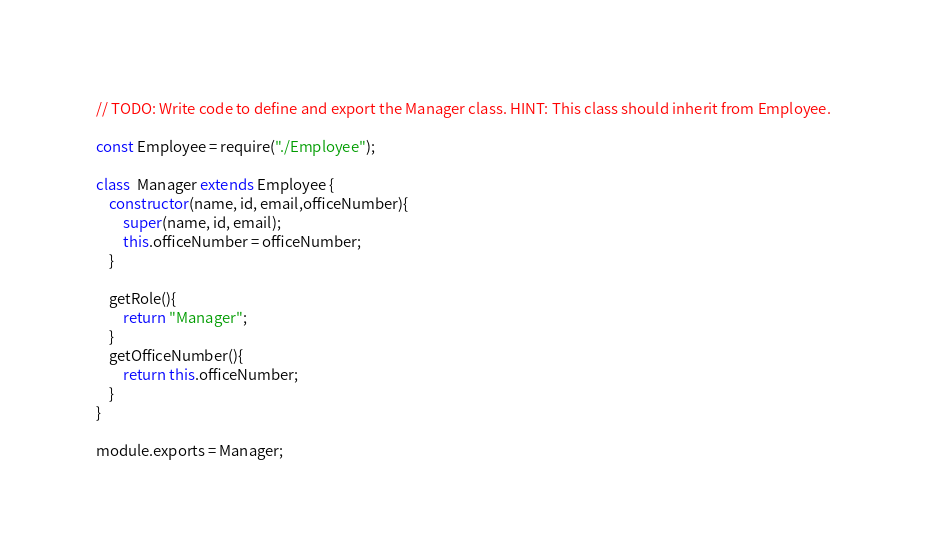<code> <loc_0><loc_0><loc_500><loc_500><_JavaScript_>// TODO: Write code to define and export the Manager class. HINT: This class should inherit from Employee.

const Employee = require("./Employee");

class  Manager extends Employee {
    constructor(name, id, email,officeNumber){
        super(name, id, email);
        this.officeNumber = officeNumber;
    }

    getRole(){
        return "Manager";
    }
    getOfficeNumber(){
        return this.officeNumber;
    }
}

module.exports = Manager;</code> 